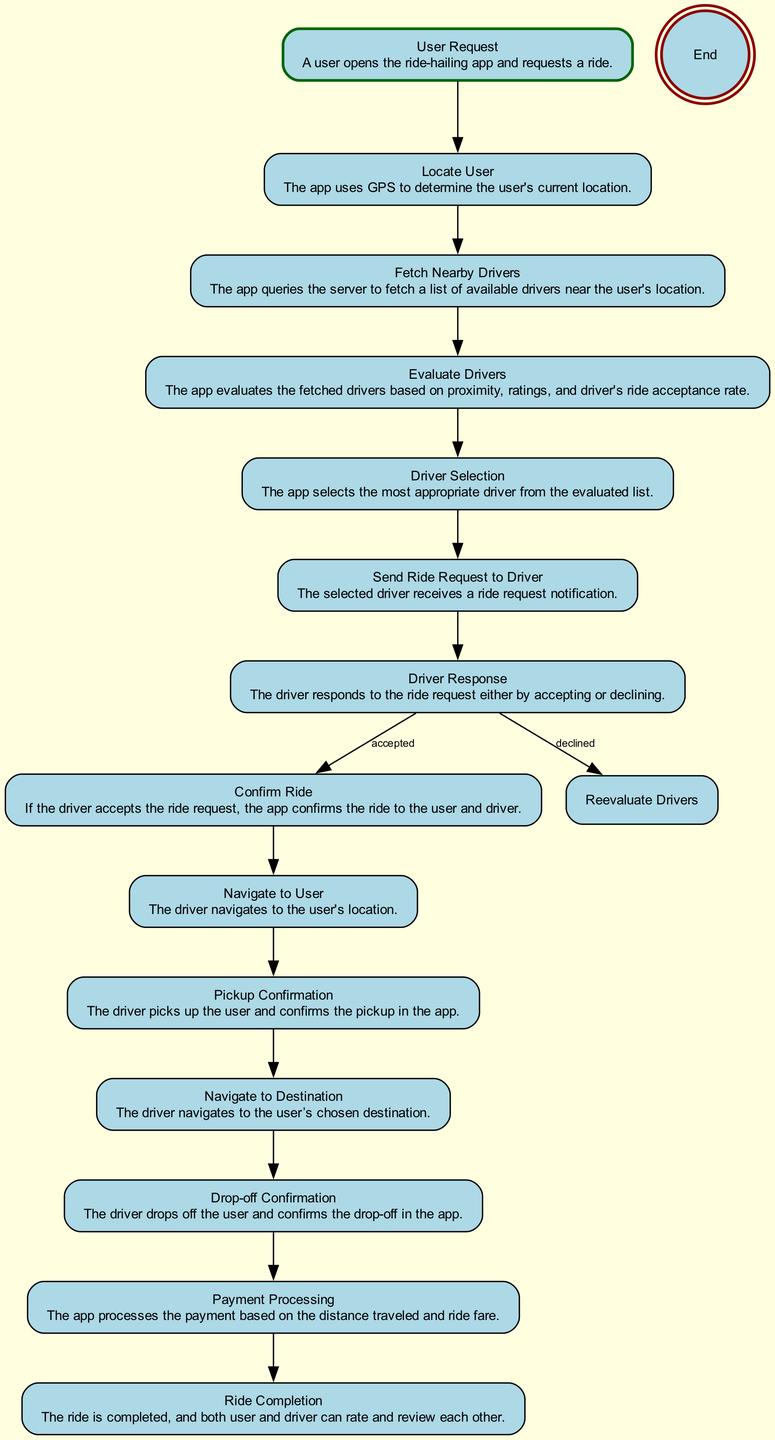What is the first step in the ride matching process? The first step is the "User Request" where a user opens the app and requests a ride. This is clearly labeled as the starting point of the flow in the diagram.
Answer: User Request How many main steps follow after the "User Request"? After "User Request," there are 13 main steps leading to "End." Counting each flow from "Locate User" to "Ride Completion" represents a sequence before reaching "End."
Answer: 13 What happens after the "Driver Response" if the driver declines the ride? If the driver declines the ride request, the flow leads to "Reevaluate Drivers." This alternative path is specified under the "nextSteps" of the "Driver Response" node.
Answer: Reevaluate Drivers Which node follows "Pickup Confirmation"? After "Pickup Confirmation," the next step in the flow is "Navigate to Destination." This shows the sequence of actions taken by the driver after confirming the pickup.
Answer: Navigate to Destination What is the final step indicated in the ride flow? The final step in the flow is "End," indicating the completion of the ride process. It is shown as the terminal node of the diagram.
Answer: End How is the "Driver Selection" process characterized in the flow? The "Driver Selection" is characterized as the step where the app selects the most appropriate driver from the evaluated list. It connects directly to the "Send Ride Request to Driver" step, governing the flow of the ride-matching process.
Answer: Selects the most appropriate driver How many times can a user expect to rate and review after their ride? A user has the opportunity to rate and review after the "Ride Completion" step, which leads to both the user and driver being able to participate in this evaluation. Hence, there will be one instance of rating and reviewing per ride.
Answer: Once What decision is made in the "Evaluate Drivers" step? In the "Evaluate Drivers" step, the app evaluates the fetched drivers based on three criteria: proximity, ratings, and driver's ride acceptance rate. This evaluation determines the subsequent actions in the process.
Answer: Evaluates based on proximity, ratings, and acceptance rate 